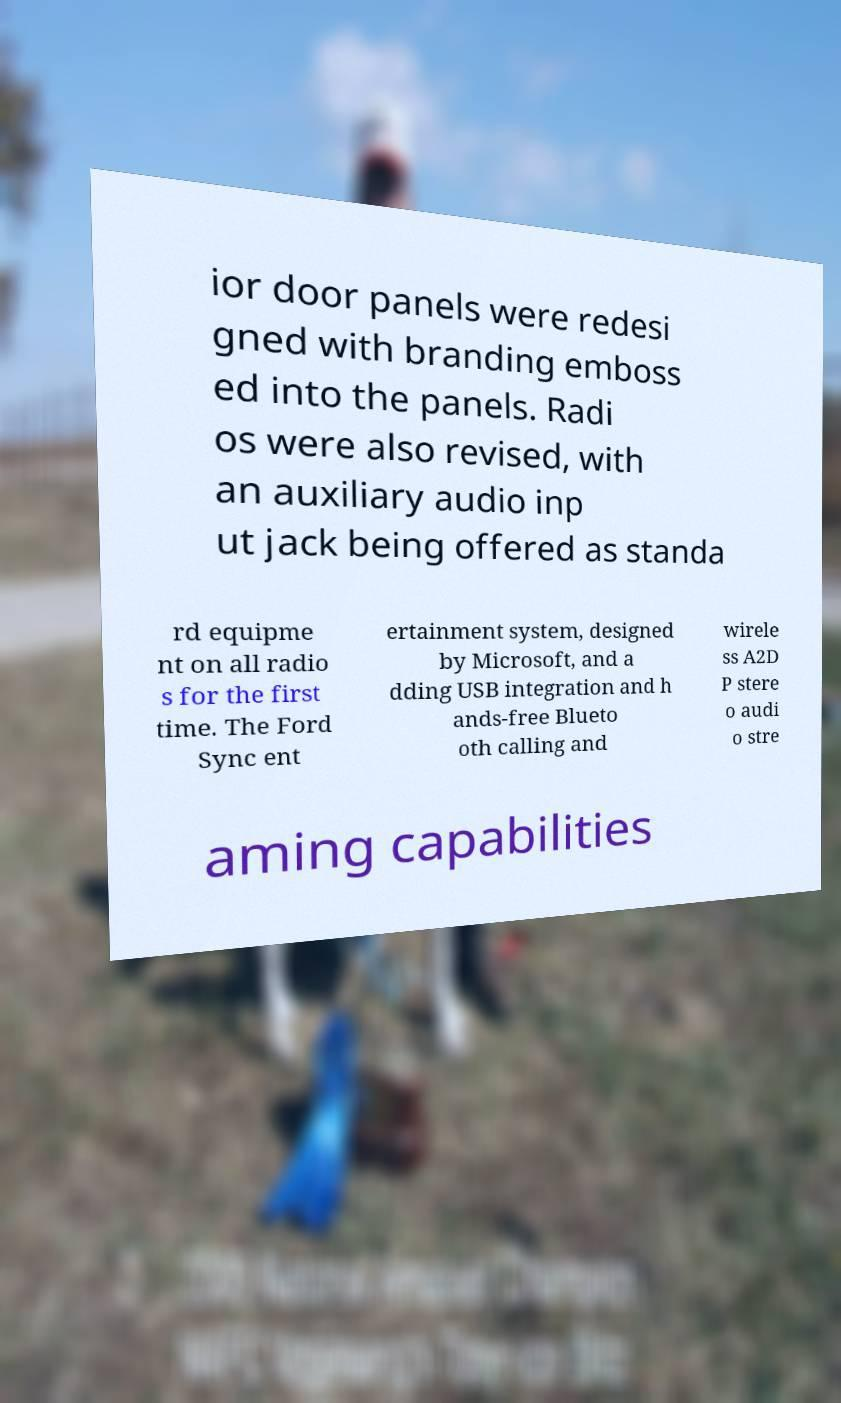There's text embedded in this image that I need extracted. Can you transcribe it verbatim? ior door panels were redesi gned with branding emboss ed into the panels. Radi os were also revised, with an auxiliary audio inp ut jack being offered as standa rd equipme nt on all radio s for the first time. The Ford Sync ent ertainment system, designed by Microsoft, and a dding USB integration and h ands-free Blueto oth calling and wirele ss A2D P stere o audi o stre aming capabilities 